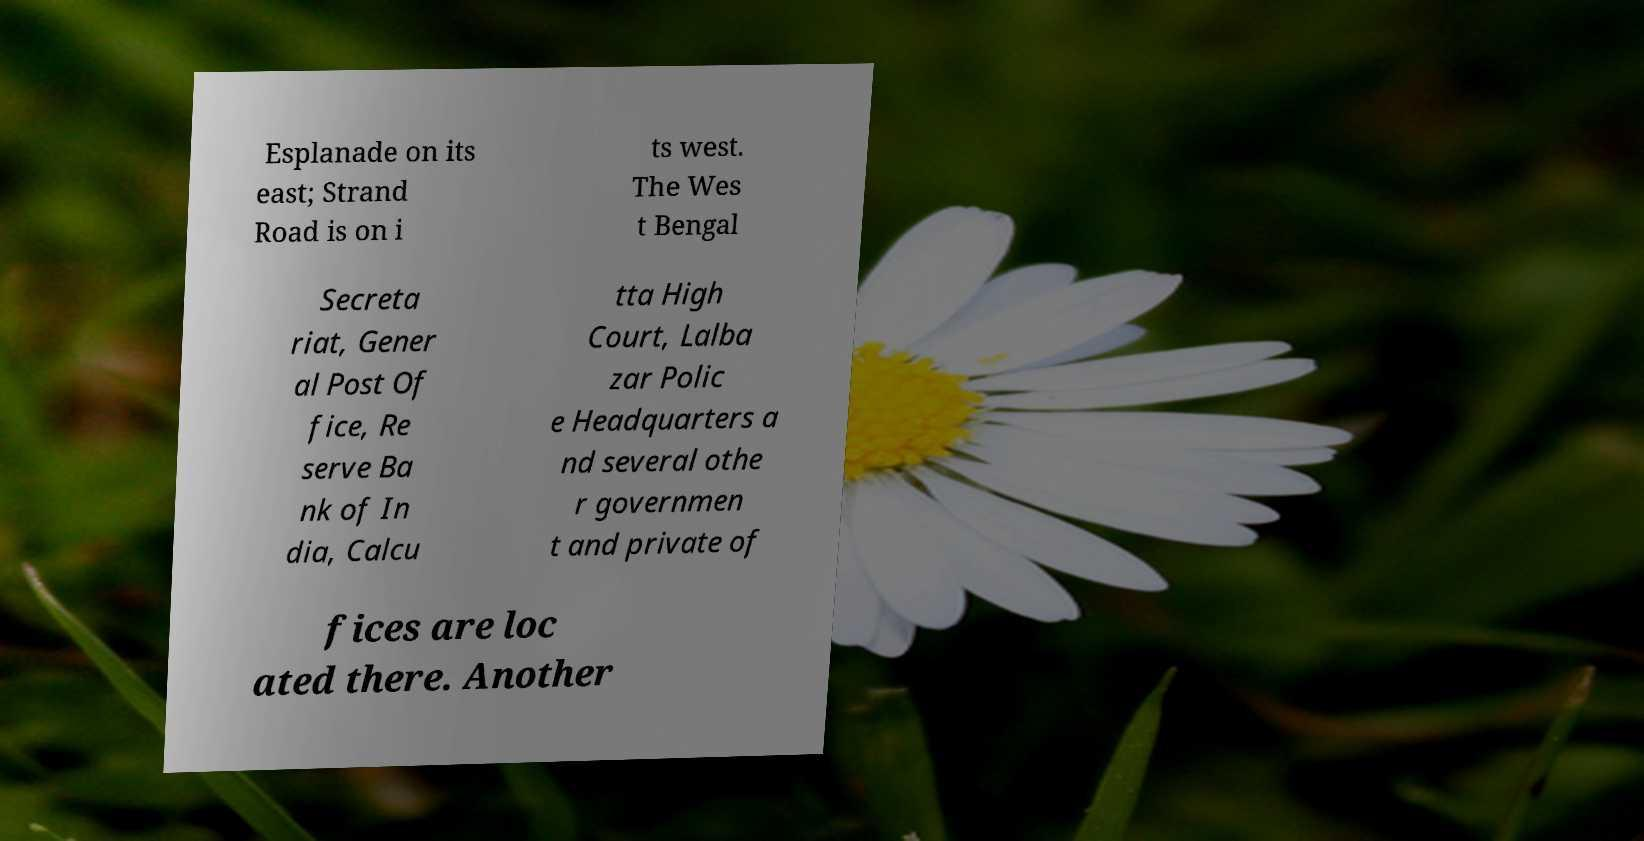I need the written content from this picture converted into text. Can you do that? Esplanade on its east; Strand Road is on i ts west. The Wes t Bengal Secreta riat, Gener al Post Of fice, Re serve Ba nk of In dia, Calcu tta High Court, Lalba zar Polic e Headquarters a nd several othe r governmen t and private of fices are loc ated there. Another 